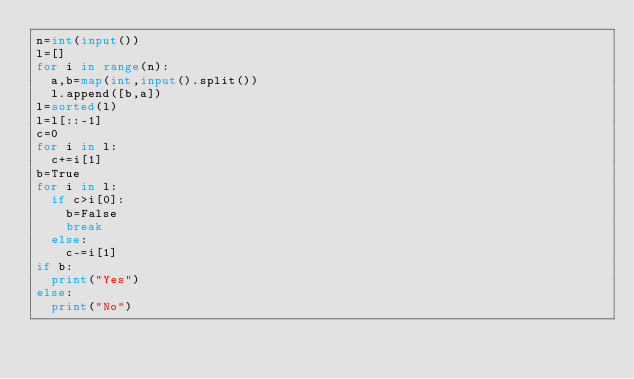<code> <loc_0><loc_0><loc_500><loc_500><_Python_>n=int(input())
l=[]
for i in range(n):
  a,b=map(int,input().split())
  l.append([b,a])
l=sorted(l)
l=l[::-1]
c=0
for i in l:
  c+=i[1]
b=True
for i in l:
  if c>i[0]:
    b=False
    break
  else:
    c-=i[1]
if b:
  print("Yes")
else:
  print("No")
</code> 